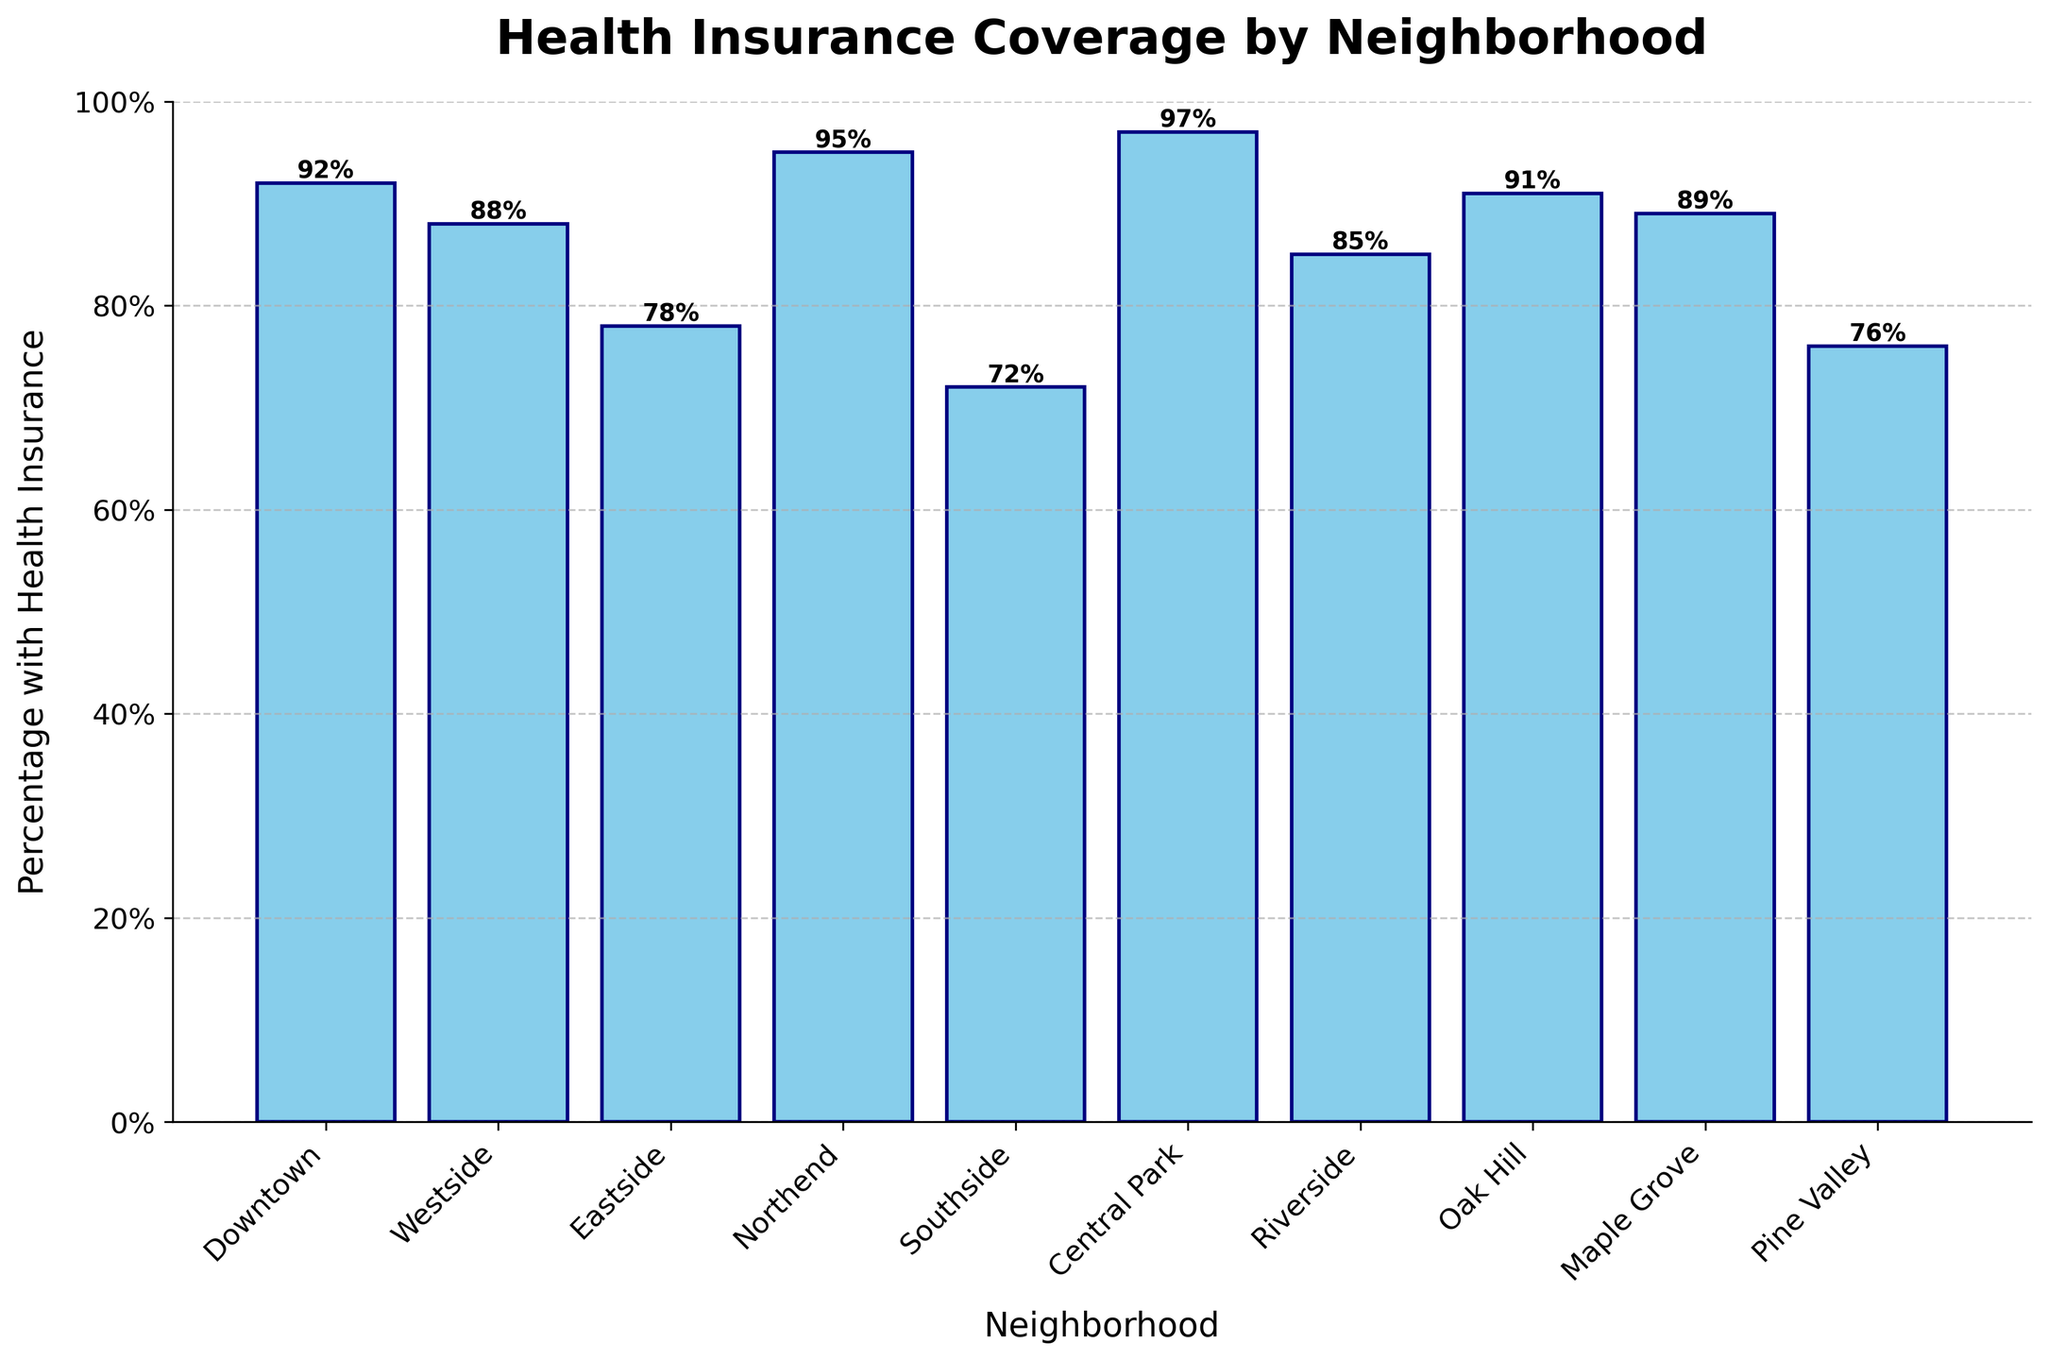What's the neighborhood with the highest percentage of health insurance coverage? By looking at the heights of the bars, we can see that the Central Park bar is the tallest, indicating the highest percentage of health insurance coverage.
Answer: Central Park Which neighborhood has the lowest percentage of health insurance coverage? The shortest bar on the chart represents the neighborhood with the lowest percentage of health insurance coverage, which is Southside.
Answer: Southside Compare the percentage of health insurance coverage between Downtown and Westside. Which one is higher? By comparing the heights of the bars for Downtown and Westside, we can see that Downtown's bar is taller, indicating a higher percentage of health insurance coverage.
Answer: Downtown Calculate the average percentage of health insurance coverage across all neighborhoods. Add the percentages and divide by the number of neighborhoods: (92 + 88 + 78 + 95 + 72 + 97 + 85 + 91 + 89 + 76) / 10 = 86.3
Answer: 86.3 What is the difference in the percentage of health insurance coverage between Northend and Pine Valley? Subtract Pine Valley's percentage from Northend's percentage: 95 - 76 = 19
Answer: 19 Identify the visual attribute used to represent the percentage of health insurance coverage. The bar heights represent the percentage of health insurance coverage, with taller bars indicating higher percentages.
Answer: Bar heights Which neighborhoods have a health insurance coverage percentage above the city average? Compare each neighborhood's percentage to the calculated average of 86.3%. The neighborhoods with percentages above this are Downtown, Northend, Central Park, Oak Hill, and Maple Grove.
Answer: Downtown, Northend, Central Park, Oak Hill, Maple Grove Are there more neighborhoods with health insurance coverage percentage above or below 90%? Count the number of neighborhoods over 90% and below 90%: Above 90% (Downtown, Northend, Central Park, Oak Hill) = 4, Below 90% (Westside, Eastside, Southside, Riverside, Maple Grove, Pine Valley) = 6
Answer: Below 90% Which neighborhood shows the closest percentage to 85% health insurance coverage? From the bars, Riverside is the closest to 85% with its bar height indicating exactly 85%.
Answer: Riverside 